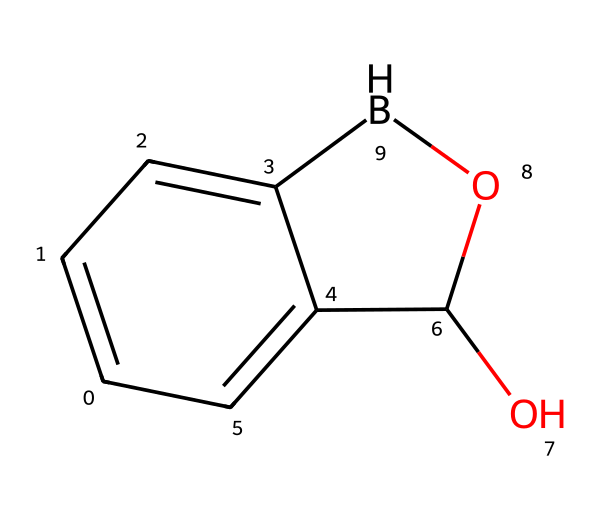What is the number of carbon atoms in this chemical? The SMILES representation indicates there are six ‘c’ characters, which represent carbon atoms in aromatic rings and one ‘C’ which is a carbon in a different context. Thus total carbon atoms are seven.
Answer: seven How many rings are present in the structure? The SMILES notation shows two interconnected aromatic systems (indicated by ‘c’), suggesting the presence of one fused bicyclic structure.
Answer: one What functional groups are present in this chemical? The presence of 'O' in the structure suggests hydroxyl (–OH) and oxy (–O–) groups, indicating that this compound possesses phenolic and ether-like functionalities.
Answer: phenolic and ether Is this compound likely to be hydrophilic or hydrophobic? The presence of hydroxyl (–OH) functional groups increases the polarity of the substance, generally leading to hydrophilic characteristics.
Answer: hydrophilic What type of chemical is this — a borane, alcohol, or ether? The structure includes boron and hydroxyl groups, classifying it primarily as a boron-containing alcohol with potential antibacterial activity.
Answer: boron-containing alcohol How many oxygen atoms are present? The structure includes one ‘O’ and one additional ‘O’ attached to the boron, giving a total of two oxygen atoms found in the compound.
Answer: two 